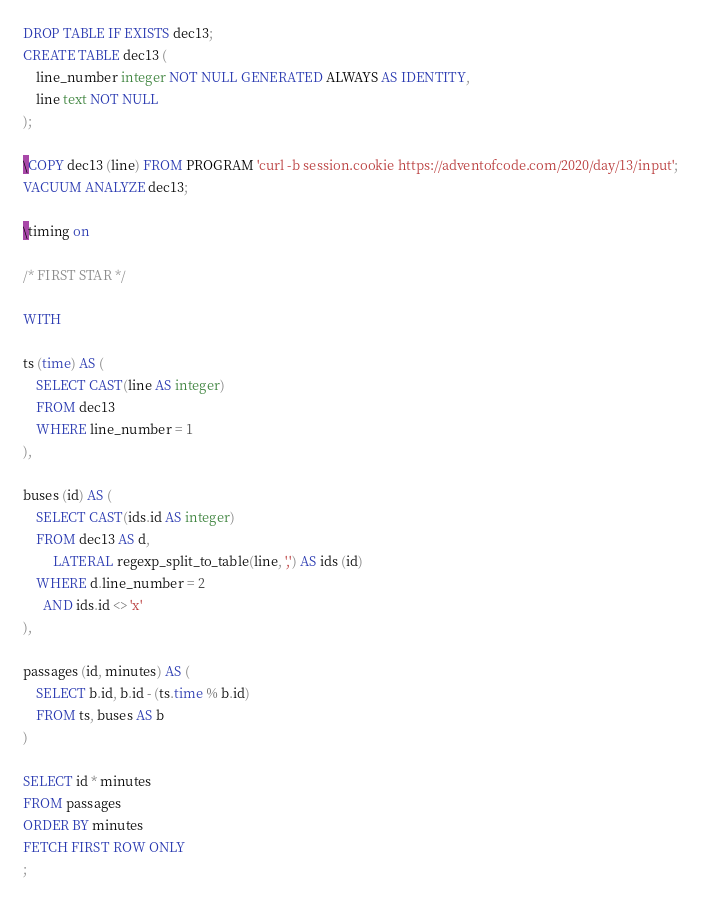<code> <loc_0><loc_0><loc_500><loc_500><_SQL_>DROP TABLE IF EXISTS dec13;
CREATE TABLE dec13 (
    line_number integer NOT NULL GENERATED ALWAYS AS IDENTITY,
    line text NOT NULL
);

\COPY dec13 (line) FROM PROGRAM 'curl -b session.cookie https://adventofcode.com/2020/day/13/input';
VACUUM ANALYZE dec13;

\timing on

/* FIRST STAR */

WITH

ts (time) AS (
    SELECT CAST(line AS integer)
    FROM dec13
    WHERE line_number = 1
),

buses (id) AS (
    SELECT CAST(ids.id AS integer)
    FROM dec13 AS d,
         LATERAL regexp_split_to_table(line, ',') AS ids (id)
    WHERE d.line_number = 2
      AND ids.id <> 'x'
),

passages (id, minutes) AS (
    SELECT b.id, b.id - (ts.time % b.id)
    FROM ts, buses AS b
)

SELECT id * minutes
FROM passages
ORDER BY minutes
FETCH FIRST ROW ONLY
;
</code> 